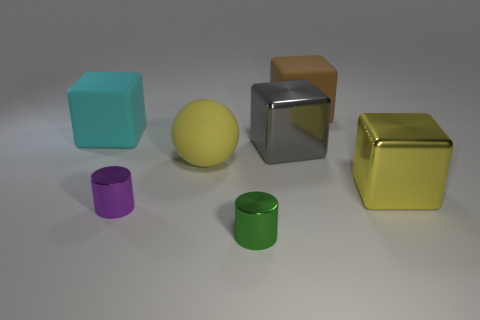Add 3 small yellow shiny spheres. How many objects exist? 10 Subtract all purple cubes. Subtract all brown spheres. How many cubes are left? 4 Subtract all spheres. How many objects are left? 6 Subtract all yellow shiny blocks. Subtract all cyan rubber blocks. How many objects are left? 5 Add 7 big cyan matte cubes. How many big cyan matte cubes are left? 8 Add 6 large balls. How many large balls exist? 7 Subtract 1 gray blocks. How many objects are left? 6 